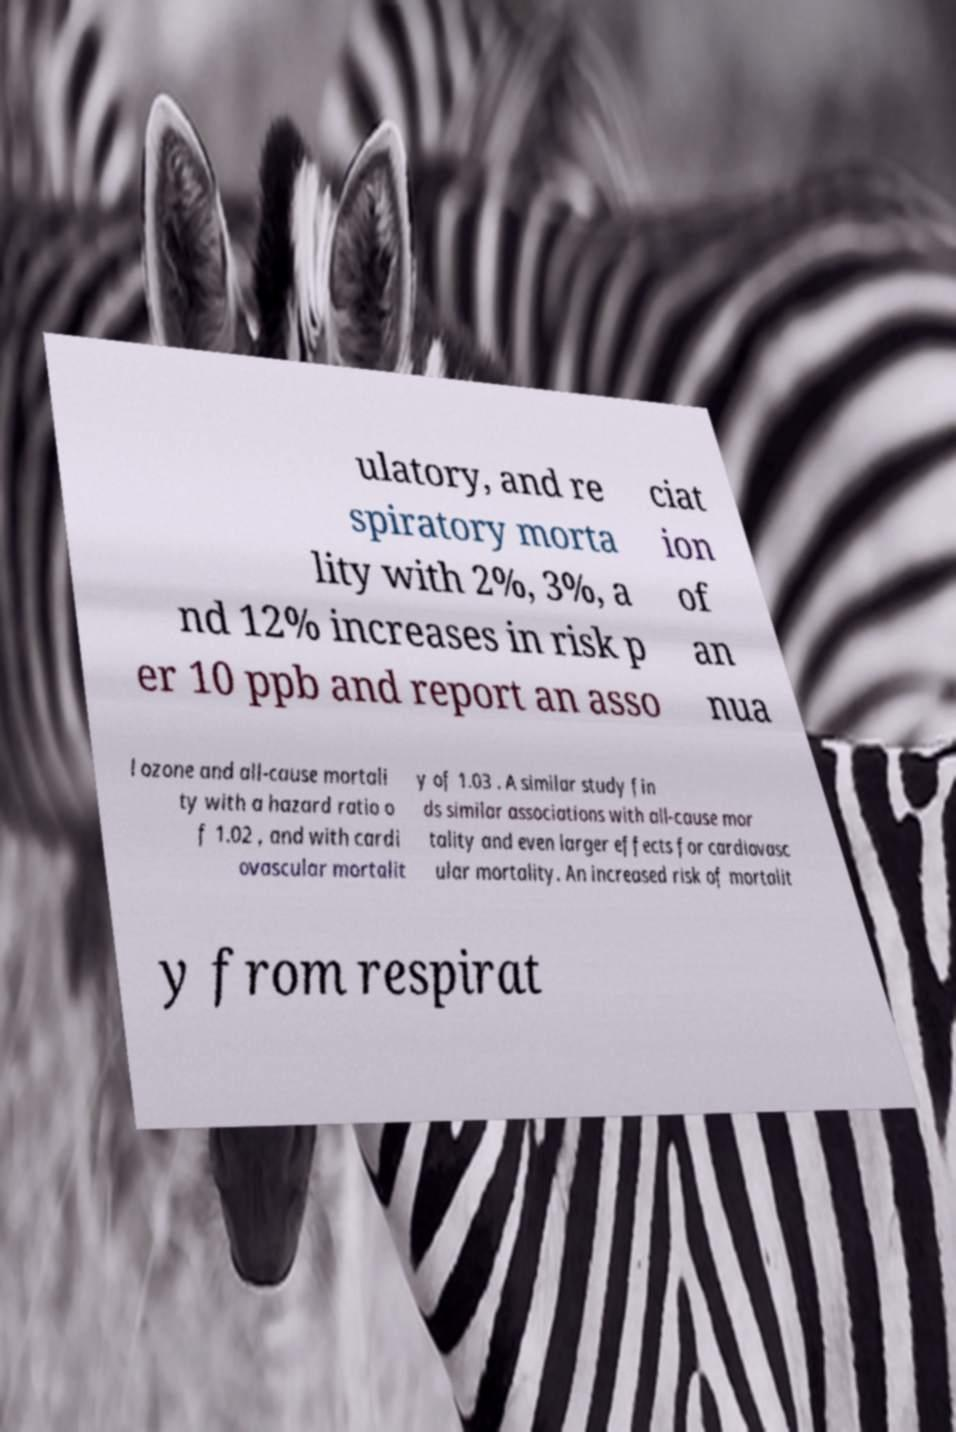For documentation purposes, I need the text within this image transcribed. Could you provide that? ulatory, and re spiratory morta lity with 2%, 3%, a nd 12% increases in risk p er 10 ppb and report an asso ciat ion of an nua l ozone and all-cause mortali ty with a hazard ratio o f 1.02 , and with cardi ovascular mortalit y of 1.03 . A similar study fin ds similar associations with all-cause mor tality and even larger effects for cardiovasc ular mortality. An increased risk of mortalit y from respirat 